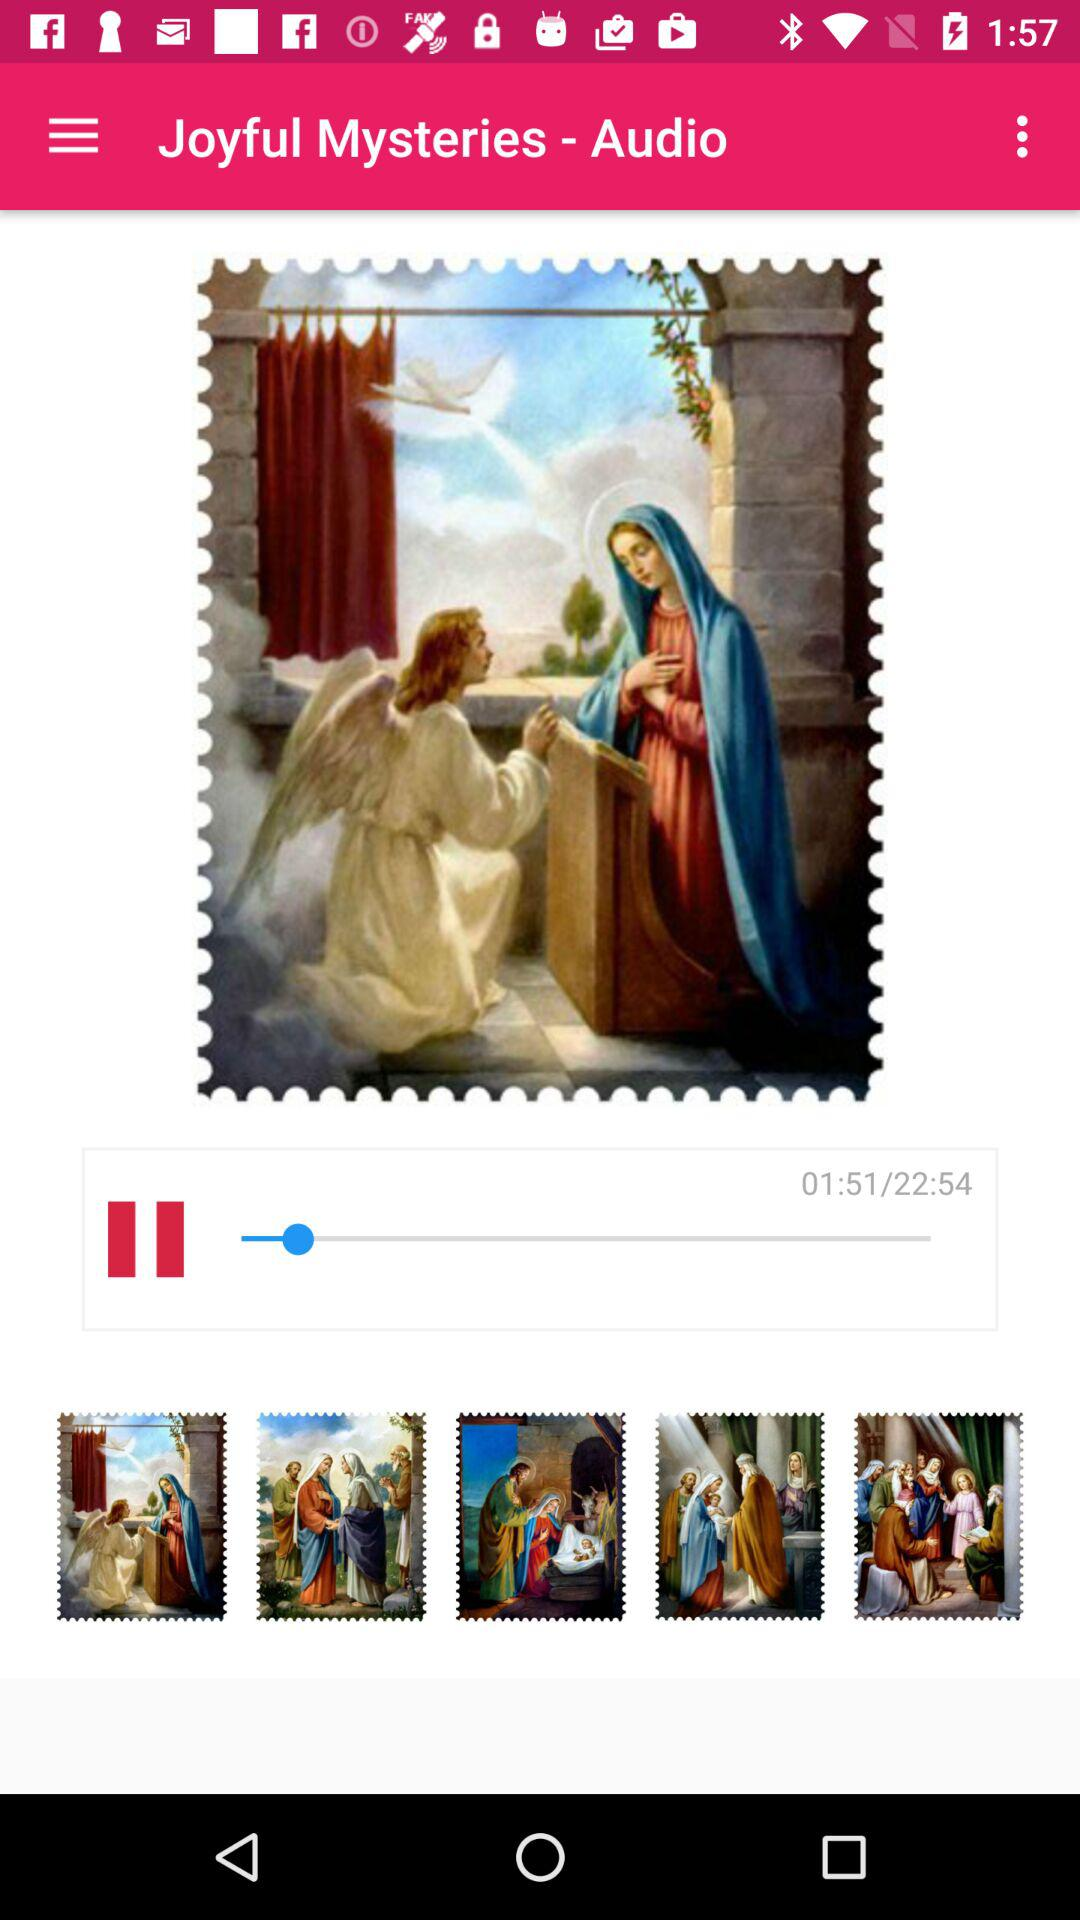What is the duration of "Joyful Mysteries" audio? The duration of "Joyful Mysteries" audio is 22 minutes 54 seconds. 